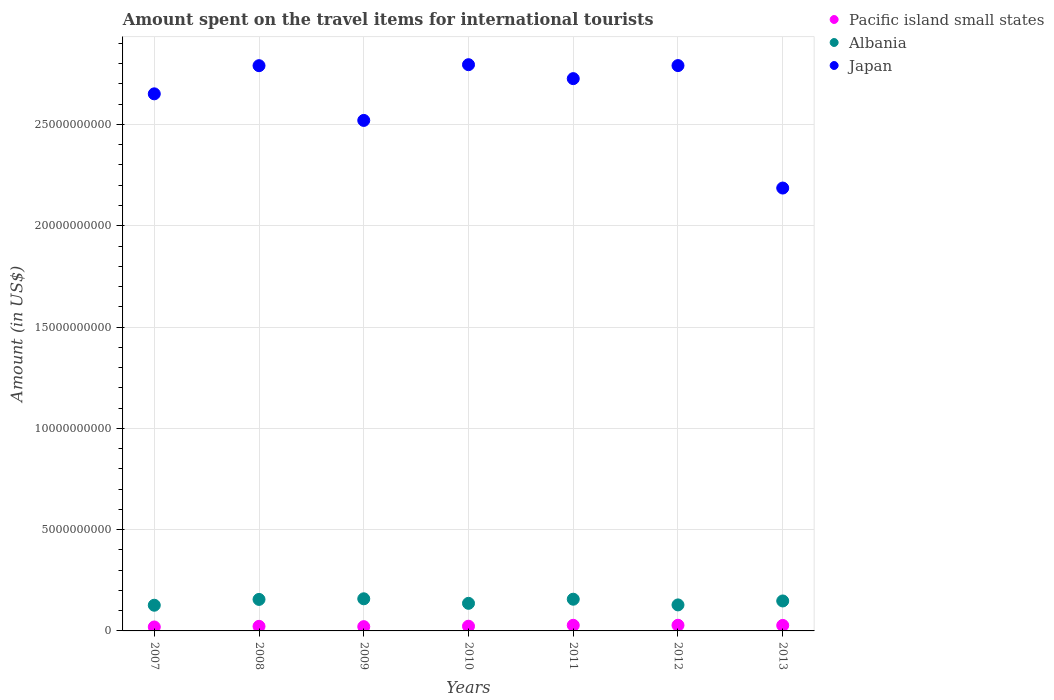How many different coloured dotlines are there?
Make the answer very short. 3. Is the number of dotlines equal to the number of legend labels?
Offer a very short reply. Yes. What is the amount spent on the travel items for international tourists in Pacific island small states in 2009?
Ensure brevity in your answer.  2.10e+08. Across all years, what is the maximum amount spent on the travel items for international tourists in Albania?
Keep it short and to the point. 1.59e+09. Across all years, what is the minimum amount spent on the travel items for international tourists in Albania?
Make the answer very short. 1.27e+09. What is the total amount spent on the travel items for international tourists in Albania in the graph?
Ensure brevity in your answer.  1.01e+1. What is the difference between the amount spent on the travel items for international tourists in Albania in 2008 and that in 2011?
Offer a terse response. -1.00e+07. What is the difference between the amount spent on the travel items for international tourists in Pacific island small states in 2011 and the amount spent on the travel items for international tourists in Japan in 2008?
Make the answer very short. -2.76e+1. What is the average amount spent on the travel items for international tourists in Albania per year?
Provide a succinct answer. 1.44e+09. In the year 2012, what is the difference between the amount spent on the travel items for international tourists in Japan and amount spent on the travel items for international tourists in Albania?
Offer a terse response. 2.66e+1. In how many years, is the amount spent on the travel items for international tourists in Japan greater than 5000000000 US$?
Offer a very short reply. 7. What is the ratio of the amount spent on the travel items for international tourists in Pacific island small states in 2010 to that in 2012?
Offer a very short reply. 0.83. What is the difference between the highest and the second highest amount spent on the travel items for international tourists in Albania?
Offer a terse response. 2.10e+07. What is the difference between the highest and the lowest amount spent on the travel items for international tourists in Albania?
Keep it short and to the point. 3.18e+08. Is the sum of the amount spent on the travel items for international tourists in Japan in 2009 and 2011 greater than the maximum amount spent on the travel items for international tourists in Pacific island small states across all years?
Provide a succinct answer. Yes. Is it the case that in every year, the sum of the amount spent on the travel items for international tourists in Japan and amount spent on the travel items for international tourists in Albania  is greater than the amount spent on the travel items for international tourists in Pacific island small states?
Offer a very short reply. Yes. Does the amount spent on the travel items for international tourists in Pacific island small states monotonically increase over the years?
Your answer should be very brief. No. Is the amount spent on the travel items for international tourists in Albania strictly greater than the amount spent on the travel items for international tourists in Japan over the years?
Provide a succinct answer. No. Are the values on the major ticks of Y-axis written in scientific E-notation?
Your answer should be very brief. No. How are the legend labels stacked?
Your answer should be compact. Vertical. What is the title of the graph?
Make the answer very short. Amount spent on the travel items for international tourists. Does "Burundi" appear as one of the legend labels in the graph?
Provide a short and direct response. No. What is the label or title of the X-axis?
Your answer should be compact. Years. What is the label or title of the Y-axis?
Your response must be concise. Amount (in US$). What is the Amount (in US$) in Pacific island small states in 2007?
Offer a terse response. 1.95e+08. What is the Amount (in US$) of Albania in 2007?
Keep it short and to the point. 1.27e+09. What is the Amount (in US$) of Japan in 2007?
Provide a succinct answer. 2.65e+1. What is the Amount (in US$) in Pacific island small states in 2008?
Provide a succinct answer. 2.26e+08. What is the Amount (in US$) of Albania in 2008?
Offer a very short reply. 1.56e+09. What is the Amount (in US$) of Japan in 2008?
Provide a short and direct response. 2.79e+1. What is the Amount (in US$) in Pacific island small states in 2009?
Ensure brevity in your answer.  2.10e+08. What is the Amount (in US$) of Albania in 2009?
Your answer should be very brief. 1.59e+09. What is the Amount (in US$) of Japan in 2009?
Offer a very short reply. 2.52e+1. What is the Amount (in US$) of Pacific island small states in 2010?
Your answer should be very brief. 2.33e+08. What is the Amount (in US$) of Albania in 2010?
Offer a terse response. 1.36e+09. What is the Amount (in US$) in Japan in 2010?
Offer a terse response. 2.80e+1. What is the Amount (in US$) in Pacific island small states in 2011?
Your response must be concise. 2.77e+08. What is the Amount (in US$) in Albania in 2011?
Ensure brevity in your answer.  1.56e+09. What is the Amount (in US$) in Japan in 2011?
Keep it short and to the point. 2.73e+1. What is the Amount (in US$) of Pacific island small states in 2012?
Keep it short and to the point. 2.80e+08. What is the Amount (in US$) of Albania in 2012?
Ensure brevity in your answer.  1.28e+09. What is the Amount (in US$) in Japan in 2012?
Keep it short and to the point. 2.79e+1. What is the Amount (in US$) of Pacific island small states in 2013?
Make the answer very short. 2.71e+08. What is the Amount (in US$) in Albania in 2013?
Keep it short and to the point. 1.48e+09. What is the Amount (in US$) of Japan in 2013?
Your response must be concise. 2.19e+1. Across all years, what is the maximum Amount (in US$) of Pacific island small states?
Offer a terse response. 2.80e+08. Across all years, what is the maximum Amount (in US$) in Albania?
Give a very brief answer. 1.59e+09. Across all years, what is the maximum Amount (in US$) of Japan?
Your answer should be very brief. 2.80e+1. Across all years, what is the minimum Amount (in US$) in Pacific island small states?
Your answer should be compact. 1.95e+08. Across all years, what is the minimum Amount (in US$) in Albania?
Ensure brevity in your answer.  1.27e+09. Across all years, what is the minimum Amount (in US$) in Japan?
Your answer should be very brief. 2.19e+1. What is the total Amount (in US$) in Pacific island small states in the graph?
Make the answer very short. 1.69e+09. What is the total Amount (in US$) of Albania in the graph?
Your answer should be very brief. 1.01e+1. What is the total Amount (in US$) in Japan in the graph?
Ensure brevity in your answer.  1.85e+11. What is the difference between the Amount (in US$) of Pacific island small states in 2007 and that in 2008?
Make the answer very short. -3.11e+07. What is the difference between the Amount (in US$) in Albania in 2007 and that in 2008?
Provide a succinct answer. -2.87e+08. What is the difference between the Amount (in US$) of Japan in 2007 and that in 2008?
Provide a succinct answer. -1.39e+09. What is the difference between the Amount (in US$) of Pacific island small states in 2007 and that in 2009?
Offer a terse response. -1.55e+07. What is the difference between the Amount (in US$) of Albania in 2007 and that in 2009?
Keep it short and to the point. -3.18e+08. What is the difference between the Amount (in US$) in Japan in 2007 and that in 2009?
Offer a terse response. 1.31e+09. What is the difference between the Amount (in US$) in Pacific island small states in 2007 and that in 2010?
Ensure brevity in your answer.  -3.79e+07. What is the difference between the Amount (in US$) in Albania in 2007 and that in 2010?
Ensure brevity in your answer.  -9.40e+07. What is the difference between the Amount (in US$) in Japan in 2007 and that in 2010?
Make the answer very short. -1.44e+09. What is the difference between the Amount (in US$) of Pacific island small states in 2007 and that in 2011?
Offer a terse response. -8.23e+07. What is the difference between the Amount (in US$) of Albania in 2007 and that in 2011?
Provide a succinct answer. -2.97e+08. What is the difference between the Amount (in US$) of Japan in 2007 and that in 2011?
Give a very brief answer. -7.51e+08. What is the difference between the Amount (in US$) of Pacific island small states in 2007 and that in 2012?
Keep it short and to the point. -8.49e+07. What is the difference between the Amount (in US$) of Albania in 2007 and that in 2012?
Offer a very short reply. -1.60e+07. What is the difference between the Amount (in US$) of Japan in 2007 and that in 2012?
Give a very brief answer. -1.40e+09. What is the difference between the Amount (in US$) in Pacific island small states in 2007 and that in 2013?
Your answer should be very brief. -7.63e+07. What is the difference between the Amount (in US$) in Albania in 2007 and that in 2013?
Provide a succinct answer. -2.11e+08. What is the difference between the Amount (in US$) of Japan in 2007 and that in 2013?
Your response must be concise. 4.65e+09. What is the difference between the Amount (in US$) of Pacific island small states in 2008 and that in 2009?
Your response must be concise. 1.57e+07. What is the difference between the Amount (in US$) in Albania in 2008 and that in 2009?
Your answer should be very brief. -3.10e+07. What is the difference between the Amount (in US$) in Japan in 2008 and that in 2009?
Offer a terse response. 2.70e+09. What is the difference between the Amount (in US$) in Pacific island small states in 2008 and that in 2010?
Your answer should be very brief. -6.73e+06. What is the difference between the Amount (in US$) of Albania in 2008 and that in 2010?
Offer a very short reply. 1.93e+08. What is the difference between the Amount (in US$) in Japan in 2008 and that in 2010?
Provide a succinct answer. -4.90e+07. What is the difference between the Amount (in US$) in Pacific island small states in 2008 and that in 2011?
Offer a terse response. -5.11e+07. What is the difference between the Amount (in US$) of Albania in 2008 and that in 2011?
Your answer should be very brief. -1.00e+07. What is the difference between the Amount (in US$) in Japan in 2008 and that in 2011?
Provide a short and direct response. 6.39e+08. What is the difference between the Amount (in US$) of Pacific island small states in 2008 and that in 2012?
Provide a short and direct response. -5.38e+07. What is the difference between the Amount (in US$) of Albania in 2008 and that in 2012?
Your answer should be very brief. 2.71e+08. What is the difference between the Amount (in US$) of Japan in 2008 and that in 2012?
Ensure brevity in your answer.  -5.00e+06. What is the difference between the Amount (in US$) of Pacific island small states in 2008 and that in 2013?
Your response must be concise. -4.52e+07. What is the difference between the Amount (in US$) in Albania in 2008 and that in 2013?
Ensure brevity in your answer.  7.60e+07. What is the difference between the Amount (in US$) of Japan in 2008 and that in 2013?
Your answer should be very brief. 6.04e+09. What is the difference between the Amount (in US$) of Pacific island small states in 2009 and that in 2010?
Provide a succinct answer. -2.24e+07. What is the difference between the Amount (in US$) of Albania in 2009 and that in 2010?
Your answer should be compact. 2.24e+08. What is the difference between the Amount (in US$) of Japan in 2009 and that in 2010?
Provide a short and direct response. -2.75e+09. What is the difference between the Amount (in US$) in Pacific island small states in 2009 and that in 2011?
Provide a succinct answer. -6.68e+07. What is the difference between the Amount (in US$) of Albania in 2009 and that in 2011?
Make the answer very short. 2.10e+07. What is the difference between the Amount (in US$) of Japan in 2009 and that in 2011?
Keep it short and to the point. -2.06e+09. What is the difference between the Amount (in US$) of Pacific island small states in 2009 and that in 2012?
Ensure brevity in your answer.  -6.94e+07. What is the difference between the Amount (in US$) in Albania in 2009 and that in 2012?
Your answer should be very brief. 3.02e+08. What is the difference between the Amount (in US$) in Japan in 2009 and that in 2012?
Offer a very short reply. -2.71e+09. What is the difference between the Amount (in US$) of Pacific island small states in 2009 and that in 2013?
Make the answer very short. -6.08e+07. What is the difference between the Amount (in US$) in Albania in 2009 and that in 2013?
Offer a very short reply. 1.07e+08. What is the difference between the Amount (in US$) in Japan in 2009 and that in 2013?
Provide a short and direct response. 3.34e+09. What is the difference between the Amount (in US$) of Pacific island small states in 2010 and that in 2011?
Give a very brief answer. -4.44e+07. What is the difference between the Amount (in US$) in Albania in 2010 and that in 2011?
Provide a short and direct response. -2.03e+08. What is the difference between the Amount (in US$) of Japan in 2010 and that in 2011?
Your answer should be compact. 6.88e+08. What is the difference between the Amount (in US$) of Pacific island small states in 2010 and that in 2012?
Your response must be concise. -4.70e+07. What is the difference between the Amount (in US$) in Albania in 2010 and that in 2012?
Give a very brief answer. 7.80e+07. What is the difference between the Amount (in US$) of Japan in 2010 and that in 2012?
Provide a short and direct response. 4.40e+07. What is the difference between the Amount (in US$) of Pacific island small states in 2010 and that in 2013?
Keep it short and to the point. -3.84e+07. What is the difference between the Amount (in US$) in Albania in 2010 and that in 2013?
Give a very brief answer. -1.17e+08. What is the difference between the Amount (in US$) in Japan in 2010 and that in 2013?
Provide a short and direct response. 6.09e+09. What is the difference between the Amount (in US$) of Pacific island small states in 2011 and that in 2012?
Provide a succinct answer. -2.63e+06. What is the difference between the Amount (in US$) in Albania in 2011 and that in 2012?
Offer a terse response. 2.81e+08. What is the difference between the Amount (in US$) in Japan in 2011 and that in 2012?
Make the answer very short. -6.44e+08. What is the difference between the Amount (in US$) in Pacific island small states in 2011 and that in 2013?
Provide a succinct answer. 5.95e+06. What is the difference between the Amount (in US$) in Albania in 2011 and that in 2013?
Make the answer very short. 8.60e+07. What is the difference between the Amount (in US$) of Japan in 2011 and that in 2013?
Ensure brevity in your answer.  5.40e+09. What is the difference between the Amount (in US$) of Pacific island small states in 2012 and that in 2013?
Make the answer very short. 8.58e+06. What is the difference between the Amount (in US$) in Albania in 2012 and that in 2013?
Provide a succinct answer. -1.95e+08. What is the difference between the Amount (in US$) of Japan in 2012 and that in 2013?
Make the answer very short. 6.04e+09. What is the difference between the Amount (in US$) in Pacific island small states in 2007 and the Amount (in US$) in Albania in 2008?
Make the answer very short. -1.36e+09. What is the difference between the Amount (in US$) of Pacific island small states in 2007 and the Amount (in US$) of Japan in 2008?
Your answer should be compact. -2.77e+1. What is the difference between the Amount (in US$) of Albania in 2007 and the Amount (in US$) of Japan in 2008?
Your response must be concise. -2.66e+1. What is the difference between the Amount (in US$) of Pacific island small states in 2007 and the Amount (in US$) of Albania in 2009?
Provide a short and direct response. -1.39e+09. What is the difference between the Amount (in US$) of Pacific island small states in 2007 and the Amount (in US$) of Japan in 2009?
Provide a short and direct response. -2.50e+1. What is the difference between the Amount (in US$) in Albania in 2007 and the Amount (in US$) in Japan in 2009?
Your response must be concise. -2.39e+1. What is the difference between the Amount (in US$) in Pacific island small states in 2007 and the Amount (in US$) in Albania in 2010?
Your response must be concise. -1.17e+09. What is the difference between the Amount (in US$) of Pacific island small states in 2007 and the Amount (in US$) of Japan in 2010?
Keep it short and to the point. -2.78e+1. What is the difference between the Amount (in US$) of Albania in 2007 and the Amount (in US$) of Japan in 2010?
Offer a very short reply. -2.67e+1. What is the difference between the Amount (in US$) of Pacific island small states in 2007 and the Amount (in US$) of Albania in 2011?
Offer a very short reply. -1.37e+09. What is the difference between the Amount (in US$) in Pacific island small states in 2007 and the Amount (in US$) in Japan in 2011?
Offer a very short reply. -2.71e+1. What is the difference between the Amount (in US$) in Albania in 2007 and the Amount (in US$) in Japan in 2011?
Provide a succinct answer. -2.60e+1. What is the difference between the Amount (in US$) of Pacific island small states in 2007 and the Amount (in US$) of Albania in 2012?
Provide a short and direct response. -1.09e+09. What is the difference between the Amount (in US$) in Pacific island small states in 2007 and the Amount (in US$) in Japan in 2012?
Provide a succinct answer. -2.77e+1. What is the difference between the Amount (in US$) of Albania in 2007 and the Amount (in US$) of Japan in 2012?
Provide a succinct answer. -2.66e+1. What is the difference between the Amount (in US$) of Pacific island small states in 2007 and the Amount (in US$) of Albania in 2013?
Provide a short and direct response. -1.28e+09. What is the difference between the Amount (in US$) of Pacific island small states in 2007 and the Amount (in US$) of Japan in 2013?
Offer a terse response. -2.17e+1. What is the difference between the Amount (in US$) of Albania in 2007 and the Amount (in US$) of Japan in 2013?
Your answer should be compact. -2.06e+1. What is the difference between the Amount (in US$) in Pacific island small states in 2008 and the Amount (in US$) in Albania in 2009?
Your answer should be very brief. -1.36e+09. What is the difference between the Amount (in US$) of Pacific island small states in 2008 and the Amount (in US$) of Japan in 2009?
Ensure brevity in your answer.  -2.50e+1. What is the difference between the Amount (in US$) of Albania in 2008 and the Amount (in US$) of Japan in 2009?
Ensure brevity in your answer.  -2.36e+1. What is the difference between the Amount (in US$) of Pacific island small states in 2008 and the Amount (in US$) of Albania in 2010?
Provide a succinct answer. -1.14e+09. What is the difference between the Amount (in US$) in Pacific island small states in 2008 and the Amount (in US$) in Japan in 2010?
Give a very brief answer. -2.77e+1. What is the difference between the Amount (in US$) of Albania in 2008 and the Amount (in US$) of Japan in 2010?
Make the answer very short. -2.64e+1. What is the difference between the Amount (in US$) of Pacific island small states in 2008 and the Amount (in US$) of Albania in 2011?
Your response must be concise. -1.34e+09. What is the difference between the Amount (in US$) in Pacific island small states in 2008 and the Amount (in US$) in Japan in 2011?
Provide a succinct answer. -2.70e+1. What is the difference between the Amount (in US$) in Albania in 2008 and the Amount (in US$) in Japan in 2011?
Provide a short and direct response. -2.57e+1. What is the difference between the Amount (in US$) of Pacific island small states in 2008 and the Amount (in US$) of Albania in 2012?
Your answer should be very brief. -1.06e+09. What is the difference between the Amount (in US$) in Pacific island small states in 2008 and the Amount (in US$) in Japan in 2012?
Keep it short and to the point. -2.77e+1. What is the difference between the Amount (in US$) in Albania in 2008 and the Amount (in US$) in Japan in 2012?
Provide a short and direct response. -2.64e+1. What is the difference between the Amount (in US$) in Pacific island small states in 2008 and the Amount (in US$) in Albania in 2013?
Provide a succinct answer. -1.25e+09. What is the difference between the Amount (in US$) of Pacific island small states in 2008 and the Amount (in US$) of Japan in 2013?
Keep it short and to the point. -2.16e+1. What is the difference between the Amount (in US$) in Albania in 2008 and the Amount (in US$) in Japan in 2013?
Offer a very short reply. -2.03e+1. What is the difference between the Amount (in US$) in Pacific island small states in 2009 and the Amount (in US$) in Albania in 2010?
Provide a succinct answer. -1.15e+09. What is the difference between the Amount (in US$) in Pacific island small states in 2009 and the Amount (in US$) in Japan in 2010?
Your response must be concise. -2.77e+1. What is the difference between the Amount (in US$) in Albania in 2009 and the Amount (in US$) in Japan in 2010?
Offer a very short reply. -2.64e+1. What is the difference between the Amount (in US$) of Pacific island small states in 2009 and the Amount (in US$) of Albania in 2011?
Your answer should be very brief. -1.35e+09. What is the difference between the Amount (in US$) in Pacific island small states in 2009 and the Amount (in US$) in Japan in 2011?
Provide a succinct answer. -2.71e+1. What is the difference between the Amount (in US$) in Albania in 2009 and the Amount (in US$) in Japan in 2011?
Ensure brevity in your answer.  -2.57e+1. What is the difference between the Amount (in US$) of Pacific island small states in 2009 and the Amount (in US$) of Albania in 2012?
Your answer should be very brief. -1.07e+09. What is the difference between the Amount (in US$) in Pacific island small states in 2009 and the Amount (in US$) in Japan in 2012?
Make the answer very short. -2.77e+1. What is the difference between the Amount (in US$) in Albania in 2009 and the Amount (in US$) in Japan in 2012?
Give a very brief answer. -2.63e+1. What is the difference between the Amount (in US$) in Pacific island small states in 2009 and the Amount (in US$) in Albania in 2013?
Provide a short and direct response. -1.27e+09. What is the difference between the Amount (in US$) of Pacific island small states in 2009 and the Amount (in US$) of Japan in 2013?
Ensure brevity in your answer.  -2.17e+1. What is the difference between the Amount (in US$) in Albania in 2009 and the Amount (in US$) in Japan in 2013?
Your answer should be compact. -2.03e+1. What is the difference between the Amount (in US$) in Pacific island small states in 2010 and the Amount (in US$) in Albania in 2011?
Provide a short and direct response. -1.33e+09. What is the difference between the Amount (in US$) of Pacific island small states in 2010 and the Amount (in US$) of Japan in 2011?
Provide a short and direct response. -2.70e+1. What is the difference between the Amount (in US$) of Albania in 2010 and the Amount (in US$) of Japan in 2011?
Ensure brevity in your answer.  -2.59e+1. What is the difference between the Amount (in US$) in Pacific island small states in 2010 and the Amount (in US$) in Albania in 2012?
Your answer should be very brief. -1.05e+09. What is the difference between the Amount (in US$) in Pacific island small states in 2010 and the Amount (in US$) in Japan in 2012?
Keep it short and to the point. -2.77e+1. What is the difference between the Amount (in US$) of Albania in 2010 and the Amount (in US$) of Japan in 2012?
Provide a short and direct response. -2.65e+1. What is the difference between the Amount (in US$) in Pacific island small states in 2010 and the Amount (in US$) in Albania in 2013?
Provide a succinct answer. -1.25e+09. What is the difference between the Amount (in US$) in Pacific island small states in 2010 and the Amount (in US$) in Japan in 2013?
Provide a succinct answer. -2.16e+1. What is the difference between the Amount (in US$) of Albania in 2010 and the Amount (in US$) of Japan in 2013?
Make the answer very short. -2.05e+1. What is the difference between the Amount (in US$) in Pacific island small states in 2011 and the Amount (in US$) in Albania in 2012?
Offer a very short reply. -1.01e+09. What is the difference between the Amount (in US$) in Pacific island small states in 2011 and the Amount (in US$) in Japan in 2012?
Offer a very short reply. -2.76e+1. What is the difference between the Amount (in US$) in Albania in 2011 and the Amount (in US$) in Japan in 2012?
Offer a terse response. -2.63e+1. What is the difference between the Amount (in US$) in Pacific island small states in 2011 and the Amount (in US$) in Albania in 2013?
Provide a succinct answer. -1.20e+09. What is the difference between the Amount (in US$) of Pacific island small states in 2011 and the Amount (in US$) of Japan in 2013?
Make the answer very short. -2.16e+1. What is the difference between the Amount (in US$) of Albania in 2011 and the Amount (in US$) of Japan in 2013?
Provide a succinct answer. -2.03e+1. What is the difference between the Amount (in US$) in Pacific island small states in 2012 and the Amount (in US$) in Albania in 2013?
Give a very brief answer. -1.20e+09. What is the difference between the Amount (in US$) of Pacific island small states in 2012 and the Amount (in US$) of Japan in 2013?
Your response must be concise. -2.16e+1. What is the difference between the Amount (in US$) in Albania in 2012 and the Amount (in US$) in Japan in 2013?
Your answer should be very brief. -2.06e+1. What is the average Amount (in US$) of Pacific island small states per year?
Offer a very short reply. 2.42e+08. What is the average Amount (in US$) in Albania per year?
Offer a terse response. 1.44e+09. What is the average Amount (in US$) in Japan per year?
Keep it short and to the point. 2.64e+1. In the year 2007, what is the difference between the Amount (in US$) in Pacific island small states and Amount (in US$) in Albania?
Provide a succinct answer. -1.07e+09. In the year 2007, what is the difference between the Amount (in US$) in Pacific island small states and Amount (in US$) in Japan?
Provide a succinct answer. -2.63e+1. In the year 2007, what is the difference between the Amount (in US$) of Albania and Amount (in US$) of Japan?
Give a very brief answer. -2.52e+1. In the year 2008, what is the difference between the Amount (in US$) of Pacific island small states and Amount (in US$) of Albania?
Your answer should be compact. -1.33e+09. In the year 2008, what is the difference between the Amount (in US$) of Pacific island small states and Amount (in US$) of Japan?
Your response must be concise. -2.77e+1. In the year 2008, what is the difference between the Amount (in US$) of Albania and Amount (in US$) of Japan?
Give a very brief answer. -2.63e+1. In the year 2009, what is the difference between the Amount (in US$) in Pacific island small states and Amount (in US$) in Albania?
Offer a very short reply. -1.38e+09. In the year 2009, what is the difference between the Amount (in US$) in Pacific island small states and Amount (in US$) in Japan?
Offer a terse response. -2.50e+1. In the year 2009, what is the difference between the Amount (in US$) in Albania and Amount (in US$) in Japan?
Your answer should be compact. -2.36e+1. In the year 2010, what is the difference between the Amount (in US$) in Pacific island small states and Amount (in US$) in Albania?
Provide a short and direct response. -1.13e+09. In the year 2010, what is the difference between the Amount (in US$) in Pacific island small states and Amount (in US$) in Japan?
Make the answer very short. -2.77e+1. In the year 2010, what is the difference between the Amount (in US$) in Albania and Amount (in US$) in Japan?
Your answer should be compact. -2.66e+1. In the year 2011, what is the difference between the Amount (in US$) of Pacific island small states and Amount (in US$) of Albania?
Offer a terse response. -1.29e+09. In the year 2011, what is the difference between the Amount (in US$) of Pacific island small states and Amount (in US$) of Japan?
Provide a short and direct response. -2.70e+1. In the year 2011, what is the difference between the Amount (in US$) in Albania and Amount (in US$) in Japan?
Offer a terse response. -2.57e+1. In the year 2012, what is the difference between the Amount (in US$) in Pacific island small states and Amount (in US$) in Albania?
Give a very brief answer. -1.00e+09. In the year 2012, what is the difference between the Amount (in US$) in Pacific island small states and Amount (in US$) in Japan?
Your answer should be compact. -2.76e+1. In the year 2012, what is the difference between the Amount (in US$) of Albania and Amount (in US$) of Japan?
Offer a terse response. -2.66e+1. In the year 2013, what is the difference between the Amount (in US$) of Pacific island small states and Amount (in US$) of Albania?
Offer a very short reply. -1.21e+09. In the year 2013, what is the difference between the Amount (in US$) of Pacific island small states and Amount (in US$) of Japan?
Your answer should be compact. -2.16e+1. In the year 2013, what is the difference between the Amount (in US$) in Albania and Amount (in US$) in Japan?
Ensure brevity in your answer.  -2.04e+1. What is the ratio of the Amount (in US$) of Pacific island small states in 2007 to that in 2008?
Keep it short and to the point. 0.86. What is the ratio of the Amount (in US$) of Albania in 2007 to that in 2008?
Provide a succinct answer. 0.82. What is the ratio of the Amount (in US$) in Japan in 2007 to that in 2008?
Your response must be concise. 0.95. What is the ratio of the Amount (in US$) of Pacific island small states in 2007 to that in 2009?
Give a very brief answer. 0.93. What is the ratio of the Amount (in US$) of Albania in 2007 to that in 2009?
Provide a short and direct response. 0.8. What is the ratio of the Amount (in US$) in Japan in 2007 to that in 2009?
Keep it short and to the point. 1.05. What is the ratio of the Amount (in US$) in Pacific island small states in 2007 to that in 2010?
Your answer should be compact. 0.84. What is the ratio of the Amount (in US$) of Albania in 2007 to that in 2010?
Keep it short and to the point. 0.93. What is the ratio of the Amount (in US$) in Japan in 2007 to that in 2010?
Offer a terse response. 0.95. What is the ratio of the Amount (in US$) in Pacific island small states in 2007 to that in 2011?
Offer a very short reply. 0.7. What is the ratio of the Amount (in US$) of Albania in 2007 to that in 2011?
Offer a very short reply. 0.81. What is the ratio of the Amount (in US$) of Japan in 2007 to that in 2011?
Your answer should be very brief. 0.97. What is the ratio of the Amount (in US$) in Pacific island small states in 2007 to that in 2012?
Provide a short and direct response. 0.7. What is the ratio of the Amount (in US$) in Albania in 2007 to that in 2012?
Your answer should be very brief. 0.99. What is the ratio of the Amount (in US$) of Pacific island small states in 2007 to that in 2013?
Offer a terse response. 0.72. What is the ratio of the Amount (in US$) in Albania in 2007 to that in 2013?
Your response must be concise. 0.86. What is the ratio of the Amount (in US$) of Japan in 2007 to that in 2013?
Your response must be concise. 1.21. What is the ratio of the Amount (in US$) in Pacific island small states in 2008 to that in 2009?
Make the answer very short. 1.07. What is the ratio of the Amount (in US$) in Albania in 2008 to that in 2009?
Provide a succinct answer. 0.98. What is the ratio of the Amount (in US$) in Japan in 2008 to that in 2009?
Provide a short and direct response. 1.11. What is the ratio of the Amount (in US$) in Pacific island small states in 2008 to that in 2010?
Provide a short and direct response. 0.97. What is the ratio of the Amount (in US$) of Albania in 2008 to that in 2010?
Ensure brevity in your answer.  1.14. What is the ratio of the Amount (in US$) of Japan in 2008 to that in 2010?
Your answer should be very brief. 1. What is the ratio of the Amount (in US$) in Pacific island small states in 2008 to that in 2011?
Your answer should be very brief. 0.82. What is the ratio of the Amount (in US$) of Albania in 2008 to that in 2011?
Keep it short and to the point. 0.99. What is the ratio of the Amount (in US$) of Japan in 2008 to that in 2011?
Give a very brief answer. 1.02. What is the ratio of the Amount (in US$) in Pacific island small states in 2008 to that in 2012?
Keep it short and to the point. 0.81. What is the ratio of the Amount (in US$) in Albania in 2008 to that in 2012?
Offer a terse response. 1.21. What is the ratio of the Amount (in US$) in Japan in 2008 to that in 2012?
Your answer should be very brief. 1. What is the ratio of the Amount (in US$) in Pacific island small states in 2008 to that in 2013?
Give a very brief answer. 0.83. What is the ratio of the Amount (in US$) of Albania in 2008 to that in 2013?
Offer a very short reply. 1.05. What is the ratio of the Amount (in US$) of Japan in 2008 to that in 2013?
Your response must be concise. 1.28. What is the ratio of the Amount (in US$) in Pacific island small states in 2009 to that in 2010?
Offer a very short reply. 0.9. What is the ratio of the Amount (in US$) of Albania in 2009 to that in 2010?
Ensure brevity in your answer.  1.16. What is the ratio of the Amount (in US$) in Japan in 2009 to that in 2010?
Keep it short and to the point. 0.9. What is the ratio of the Amount (in US$) in Pacific island small states in 2009 to that in 2011?
Provide a succinct answer. 0.76. What is the ratio of the Amount (in US$) of Albania in 2009 to that in 2011?
Your answer should be compact. 1.01. What is the ratio of the Amount (in US$) in Japan in 2009 to that in 2011?
Provide a short and direct response. 0.92. What is the ratio of the Amount (in US$) in Pacific island small states in 2009 to that in 2012?
Provide a succinct answer. 0.75. What is the ratio of the Amount (in US$) in Albania in 2009 to that in 2012?
Provide a succinct answer. 1.24. What is the ratio of the Amount (in US$) of Japan in 2009 to that in 2012?
Your answer should be compact. 0.9. What is the ratio of the Amount (in US$) of Pacific island small states in 2009 to that in 2013?
Your answer should be very brief. 0.78. What is the ratio of the Amount (in US$) in Albania in 2009 to that in 2013?
Your answer should be very brief. 1.07. What is the ratio of the Amount (in US$) in Japan in 2009 to that in 2013?
Your response must be concise. 1.15. What is the ratio of the Amount (in US$) in Pacific island small states in 2010 to that in 2011?
Your answer should be compact. 0.84. What is the ratio of the Amount (in US$) of Albania in 2010 to that in 2011?
Provide a succinct answer. 0.87. What is the ratio of the Amount (in US$) in Japan in 2010 to that in 2011?
Keep it short and to the point. 1.03. What is the ratio of the Amount (in US$) in Pacific island small states in 2010 to that in 2012?
Your response must be concise. 0.83. What is the ratio of the Amount (in US$) in Albania in 2010 to that in 2012?
Your answer should be very brief. 1.06. What is the ratio of the Amount (in US$) of Pacific island small states in 2010 to that in 2013?
Your answer should be very brief. 0.86. What is the ratio of the Amount (in US$) of Albania in 2010 to that in 2013?
Make the answer very short. 0.92. What is the ratio of the Amount (in US$) in Japan in 2010 to that in 2013?
Offer a very short reply. 1.28. What is the ratio of the Amount (in US$) of Pacific island small states in 2011 to that in 2012?
Give a very brief answer. 0.99. What is the ratio of the Amount (in US$) in Albania in 2011 to that in 2012?
Your response must be concise. 1.22. What is the ratio of the Amount (in US$) of Japan in 2011 to that in 2012?
Your response must be concise. 0.98. What is the ratio of the Amount (in US$) in Pacific island small states in 2011 to that in 2013?
Give a very brief answer. 1.02. What is the ratio of the Amount (in US$) of Albania in 2011 to that in 2013?
Your answer should be compact. 1.06. What is the ratio of the Amount (in US$) of Japan in 2011 to that in 2013?
Provide a succinct answer. 1.25. What is the ratio of the Amount (in US$) of Pacific island small states in 2012 to that in 2013?
Your answer should be compact. 1.03. What is the ratio of the Amount (in US$) in Albania in 2012 to that in 2013?
Your answer should be very brief. 0.87. What is the ratio of the Amount (in US$) in Japan in 2012 to that in 2013?
Your answer should be very brief. 1.28. What is the difference between the highest and the second highest Amount (in US$) of Pacific island small states?
Provide a short and direct response. 2.63e+06. What is the difference between the highest and the second highest Amount (in US$) of Albania?
Provide a succinct answer. 2.10e+07. What is the difference between the highest and the second highest Amount (in US$) of Japan?
Provide a short and direct response. 4.40e+07. What is the difference between the highest and the lowest Amount (in US$) in Pacific island small states?
Your response must be concise. 8.49e+07. What is the difference between the highest and the lowest Amount (in US$) in Albania?
Provide a succinct answer. 3.18e+08. What is the difference between the highest and the lowest Amount (in US$) in Japan?
Make the answer very short. 6.09e+09. 